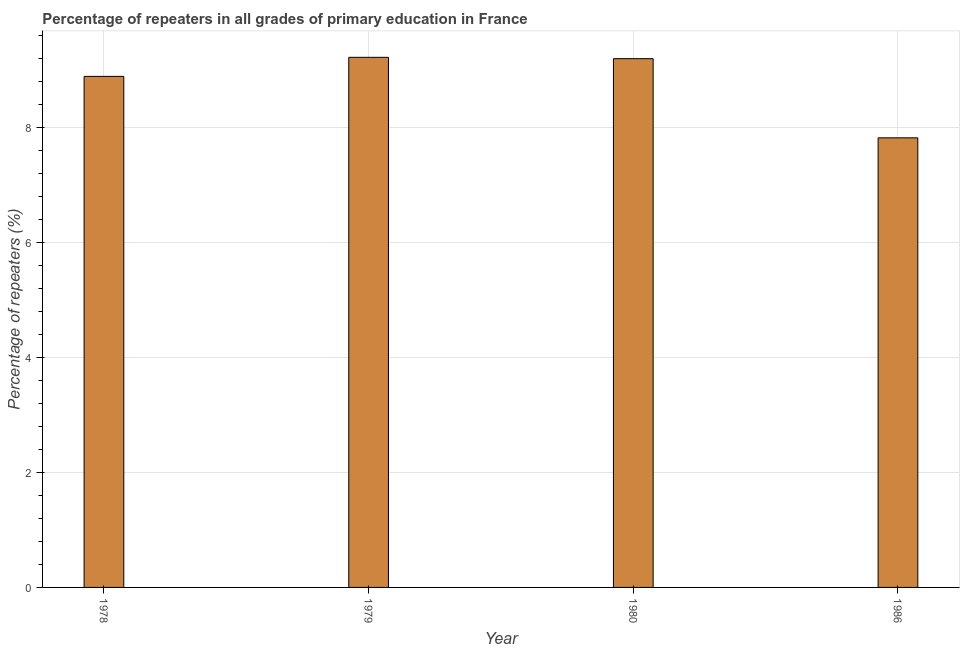What is the title of the graph?
Make the answer very short. Percentage of repeaters in all grades of primary education in France. What is the label or title of the X-axis?
Give a very brief answer. Year. What is the label or title of the Y-axis?
Provide a succinct answer. Percentage of repeaters (%). What is the percentage of repeaters in primary education in 1986?
Give a very brief answer. 7.82. Across all years, what is the maximum percentage of repeaters in primary education?
Keep it short and to the point. 9.22. Across all years, what is the minimum percentage of repeaters in primary education?
Provide a short and direct response. 7.82. In which year was the percentage of repeaters in primary education maximum?
Your answer should be very brief. 1979. In which year was the percentage of repeaters in primary education minimum?
Your response must be concise. 1986. What is the sum of the percentage of repeaters in primary education?
Provide a short and direct response. 35.11. What is the difference between the percentage of repeaters in primary education in 1978 and 1986?
Provide a succinct answer. 1.07. What is the average percentage of repeaters in primary education per year?
Provide a succinct answer. 8.78. What is the median percentage of repeaters in primary education?
Offer a very short reply. 9.04. What is the ratio of the percentage of repeaters in primary education in 1979 to that in 1980?
Your response must be concise. 1. What is the difference between the highest and the second highest percentage of repeaters in primary education?
Make the answer very short. 0.02. What is the difference between the highest and the lowest percentage of repeaters in primary education?
Offer a very short reply. 1.4. How many bars are there?
Your answer should be compact. 4. Are all the bars in the graph horizontal?
Make the answer very short. No. Are the values on the major ticks of Y-axis written in scientific E-notation?
Make the answer very short. No. What is the Percentage of repeaters (%) of 1978?
Give a very brief answer. 8.88. What is the Percentage of repeaters (%) of 1979?
Your answer should be compact. 9.22. What is the Percentage of repeaters (%) of 1980?
Make the answer very short. 9.19. What is the Percentage of repeaters (%) of 1986?
Make the answer very short. 7.82. What is the difference between the Percentage of repeaters (%) in 1978 and 1979?
Your answer should be very brief. -0.33. What is the difference between the Percentage of repeaters (%) in 1978 and 1980?
Provide a succinct answer. -0.31. What is the difference between the Percentage of repeaters (%) in 1978 and 1986?
Make the answer very short. 1.07. What is the difference between the Percentage of repeaters (%) in 1979 and 1980?
Give a very brief answer. 0.02. What is the difference between the Percentage of repeaters (%) in 1979 and 1986?
Provide a succinct answer. 1.4. What is the difference between the Percentage of repeaters (%) in 1980 and 1986?
Make the answer very short. 1.38. What is the ratio of the Percentage of repeaters (%) in 1978 to that in 1979?
Make the answer very short. 0.96. What is the ratio of the Percentage of repeaters (%) in 1978 to that in 1986?
Make the answer very short. 1.14. What is the ratio of the Percentage of repeaters (%) in 1979 to that in 1980?
Keep it short and to the point. 1. What is the ratio of the Percentage of repeaters (%) in 1979 to that in 1986?
Your answer should be very brief. 1.18. What is the ratio of the Percentage of repeaters (%) in 1980 to that in 1986?
Your answer should be very brief. 1.18. 